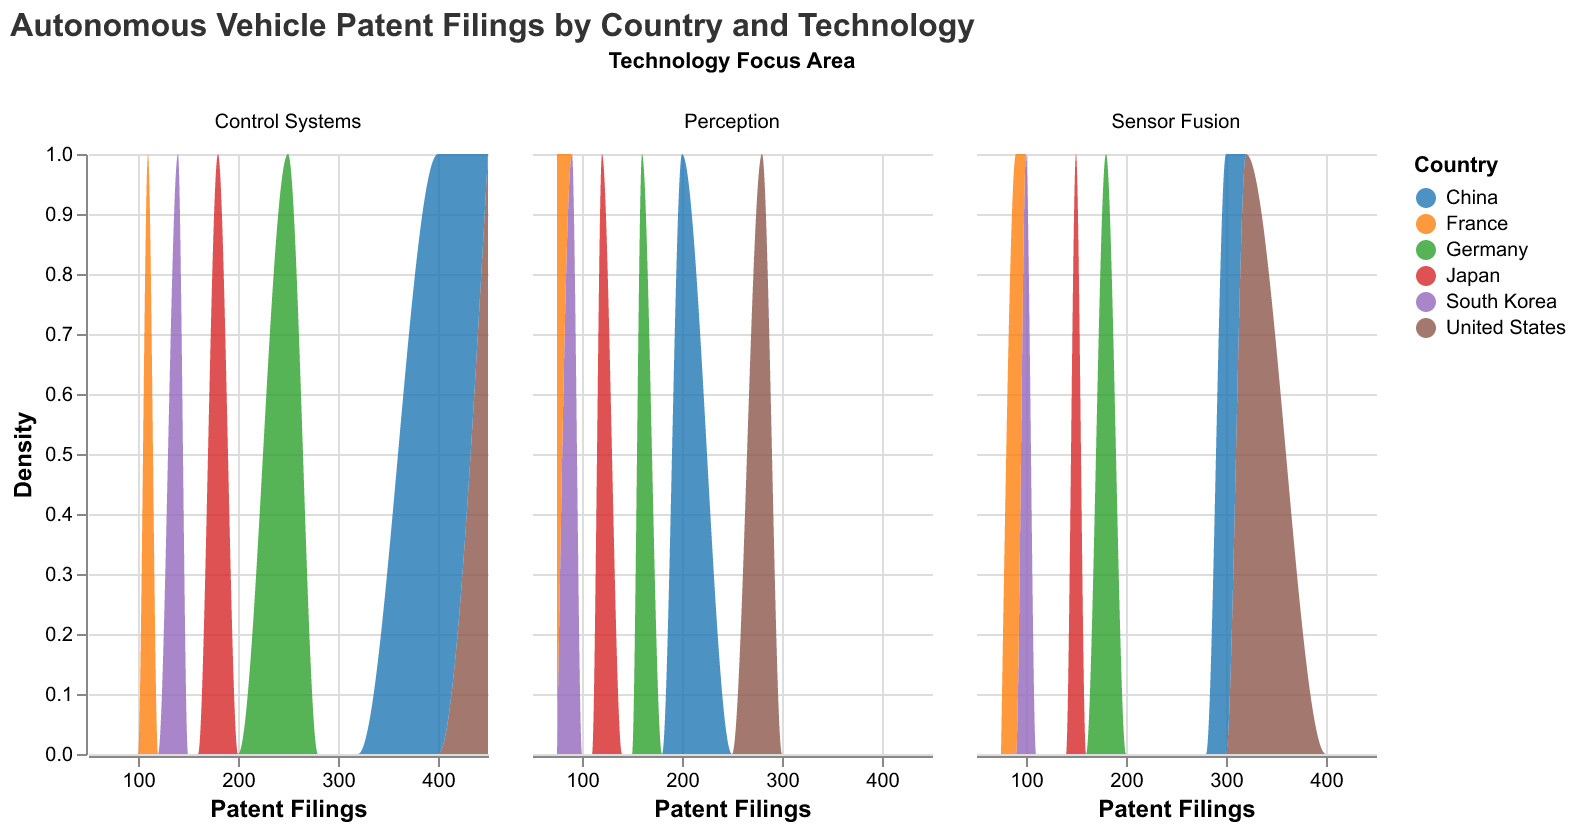What is the title of the figure? The title appears at the top of the figure. It states "Autonomous Vehicle Patent Filings by Country and Technology".
Answer: Autonomous Vehicle Patent Filings by Country and Technology How is the data divided by Technology Focus Areas? The figure is faceted into three columns, each representing a different Technology Focus Area: Sensor Fusion, Perception, and Control Systems.
Answer: Sensor Fusion, Perception, Control Systems Which country has the most patent filings for Control Systems? Looking at the Control Systems panel, the United States has the highest density towards the right side of the x-axis, indicating the most filings.
Answer: United States Which two countries have the closest number of patent filings for Sensor Fusion? By comparing the density curves in the Sensor Fusion panel, we see that China and the United States have similar densities but China is slightly lower.
Answer: United States and China What's the difference in patent filings between Japan and Germany for Perception? By comparing the density peaks in the Perception panel, Japan's peak is much lower at around 120 filings while Germany's peak is around 160 filings: 160 - 120 = 40.
Answer: 40 In which technology focus area does South Korea have the lowest density? Comparing the three panels, South Korea's density is lowest in the Perception panel.
Answer: Perception Which country has the highest density for Sensor Fusion technology? In the Sensor Fusion panel, the United States has the furthest right and highest density curve.
Answer: United States What is the range of patent filings in the Control Systems focus area? In the Control Systems panel, the x-axis ranges from around 100 to around 450.
Answer: 100 to 450 How does the density of Control Systems filings in China compare to that in Japan? The density for China peaks much higher and more right-shifted compared to Japan's lower and left-shifted density in the Control Systems panel.
Answer: Higher and more right-shifted Which country appears to have a generally lower number of patent filings across all technologies? France has the generally lower patent filings with the lowest density curves in all three panels.
Answer: France 